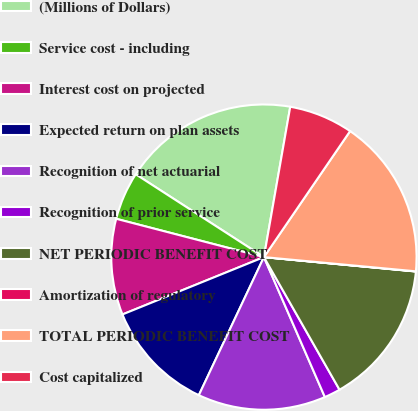<chart> <loc_0><loc_0><loc_500><loc_500><pie_chart><fcel>(Millions of Dollars)<fcel>Service cost - including<fcel>Interest cost on projected<fcel>Expected return on plan assets<fcel>Recognition of net actuarial<fcel>Recognition of prior service<fcel>NET PERIODIC BENEFIT COST<fcel>Amortization of regulatory<fcel>TOTAL PERIODIC BENEFIT COST<fcel>Cost capitalized<nl><fcel>18.63%<fcel>5.09%<fcel>10.17%<fcel>11.86%<fcel>13.55%<fcel>1.71%<fcel>15.25%<fcel>0.02%<fcel>16.94%<fcel>6.79%<nl></chart> 